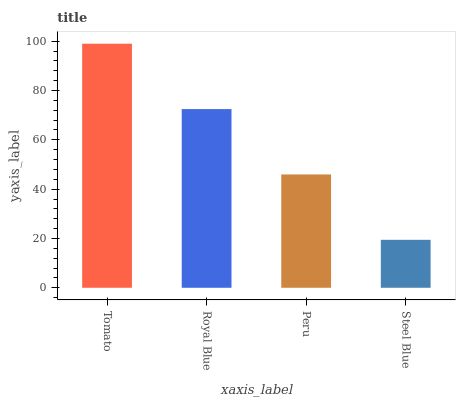Is Steel Blue the minimum?
Answer yes or no. Yes. Is Tomato the maximum?
Answer yes or no. Yes. Is Royal Blue the minimum?
Answer yes or no. No. Is Royal Blue the maximum?
Answer yes or no. No. Is Tomato greater than Royal Blue?
Answer yes or no. Yes. Is Royal Blue less than Tomato?
Answer yes or no. Yes. Is Royal Blue greater than Tomato?
Answer yes or no. No. Is Tomato less than Royal Blue?
Answer yes or no. No. Is Royal Blue the high median?
Answer yes or no. Yes. Is Peru the low median?
Answer yes or no. Yes. Is Peru the high median?
Answer yes or no. No. Is Tomato the low median?
Answer yes or no. No. 